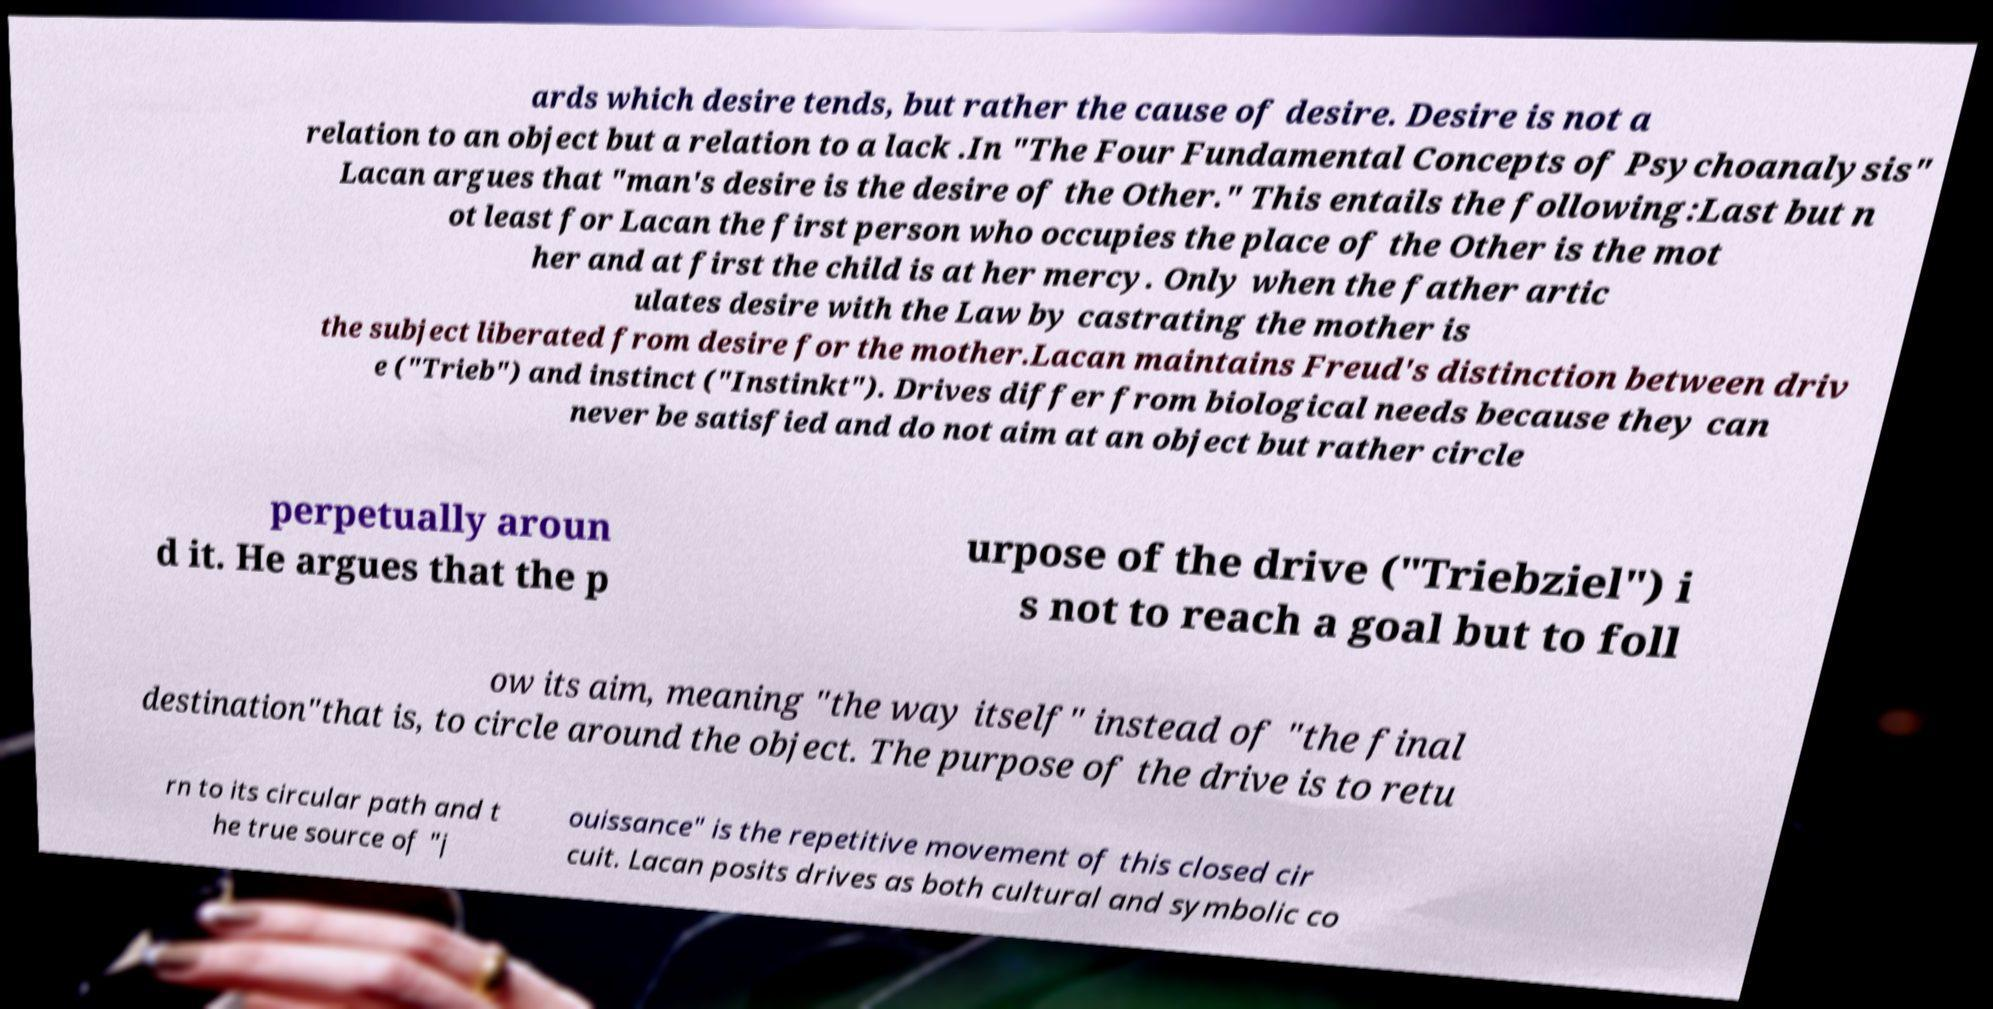For documentation purposes, I need the text within this image transcribed. Could you provide that? ards which desire tends, but rather the cause of desire. Desire is not a relation to an object but a relation to a lack .In "The Four Fundamental Concepts of Psychoanalysis" Lacan argues that "man's desire is the desire of the Other." This entails the following:Last but n ot least for Lacan the first person who occupies the place of the Other is the mot her and at first the child is at her mercy. Only when the father artic ulates desire with the Law by castrating the mother is the subject liberated from desire for the mother.Lacan maintains Freud's distinction between driv e ("Trieb") and instinct ("Instinkt"). Drives differ from biological needs because they can never be satisfied and do not aim at an object but rather circle perpetually aroun d it. He argues that the p urpose of the drive ("Triebziel") i s not to reach a goal but to foll ow its aim, meaning "the way itself" instead of "the final destination"that is, to circle around the object. The purpose of the drive is to retu rn to its circular path and t he true source of "j ouissance" is the repetitive movement of this closed cir cuit. Lacan posits drives as both cultural and symbolic co 